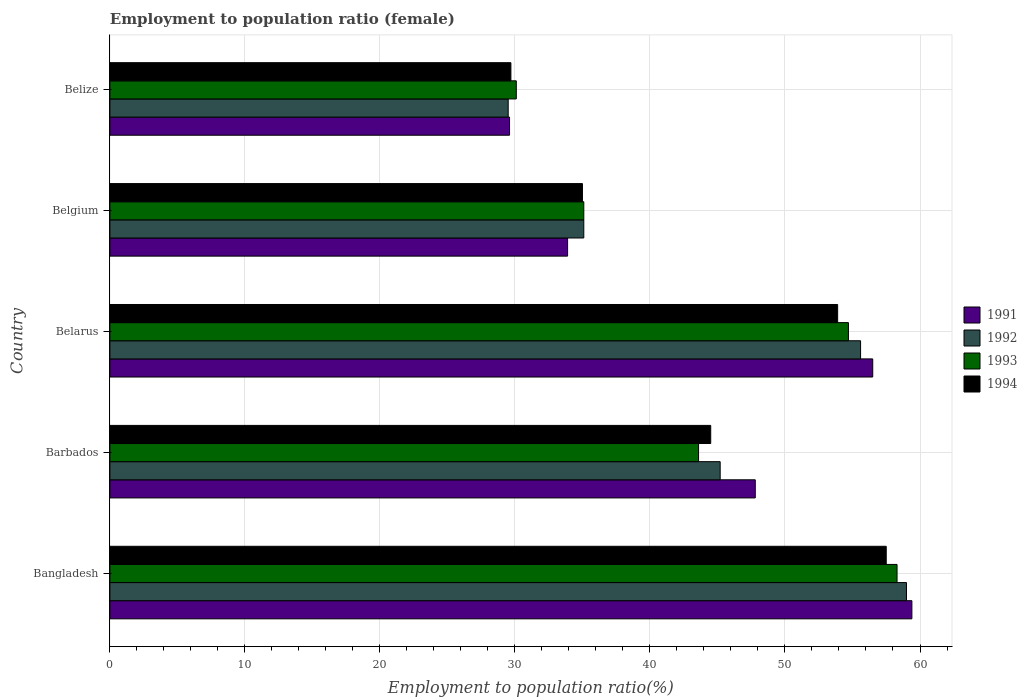How many different coloured bars are there?
Your response must be concise. 4. How many groups of bars are there?
Offer a terse response. 5. Are the number of bars on each tick of the Y-axis equal?
Offer a very short reply. Yes. How many bars are there on the 2nd tick from the top?
Keep it short and to the point. 4. What is the employment to population ratio in 1992 in Barbados?
Provide a short and direct response. 45.2. Across all countries, what is the maximum employment to population ratio in 1994?
Provide a short and direct response. 57.5. Across all countries, what is the minimum employment to population ratio in 1992?
Give a very brief answer. 29.5. In which country was the employment to population ratio in 1992 maximum?
Give a very brief answer. Bangladesh. In which country was the employment to population ratio in 1994 minimum?
Ensure brevity in your answer.  Belize. What is the total employment to population ratio in 1994 in the graph?
Offer a very short reply. 220.6. What is the difference between the employment to population ratio in 1993 in Bangladesh and that in Belgium?
Keep it short and to the point. 23.2. What is the difference between the employment to population ratio in 1991 in Bangladesh and the employment to population ratio in 1994 in Belgium?
Give a very brief answer. 24.4. What is the average employment to population ratio in 1993 per country?
Provide a succinct answer. 44.36. What is the difference between the employment to population ratio in 1992 and employment to population ratio in 1994 in Belize?
Make the answer very short. -0.2. In how many countries, is the employment to population ratio in 1991 greater than 58 %?
Provide a succinct answer. 1. What is the ratio of the employment to population ratio in 1994 in Belarus to that in Belize?
Your response must be concise. 1.81. Is the difference between the employment to population ratio in 1992 in Barbados and Belize greater than the difference between the employment to population ratio in 1994 in Barbados and Belize?
Offer a terse response. Yes. What is the difference between the highest and the second highest employment to population ratio in 1991?
Offer a terse response. 2.9. What is the difference between the highest and the lowest employment to population ratio in 1992?
Your response must be concise. 29.5. In how many countries, is the employment to population ratio in 1991 greater than the average employment to population ratio in 1991 taken over all countries?
Your response must be concise. 3. Is it the case that in every country, the sum of the employment to population ratio in 1994 and employment to population ratio in 1991 is greater than the sum of employment to population ratio in 1993 and employment to population ratio in 1992?
Provide a succinct answer. No. What does the 1st bar from the top in Bangladesh represents?
Make the answer very short. 1994. How many bars are there?
Ensure brevity in your answer.  20. Are all the bars in the graph horizontal?
Provide a succinct answer. Yes. What is the difference between two consecutive major ticks on the X-axis?
Your answer should be compact. 10. Are the values on the major ticks of X-axis written in scientific E-notation?
Keep it short and to the point. No. Does the graph contain any zero values?
Offer a terse response. No. Where does the legend appear in the graph?
Give a very brief answer. Center right. How are the legend labels stacked?
Your answer should be compact. Vertical. What is the title of the graph?
Ensure brevity in your answer.  Employment to population ratio (female). Does "1995" appear as one of the legend labels in the graph?
Provide a short and direct response. No. What is the label or title of the Y-axis?
Your response must be concise. Country. What is the Employment to population ratio(%) in 1991 in Bangladesh?
Provide a short and direct response. 59.4. What is the Employment to population ratio(%) of 1992 in Bangladesh?
Your answer should be very brief. 59. What is the Employment to population ratio(%) in 1993 in Bangladesh?
Your answer should be compact. 58.3. What is the Employment to population ratio(%) in 1994 in Bangladesh?
Offer a very short reply. 57.5. What is the Employment to population ratio(%) in 1991 in Barbados?
Ensure brevity in your answer.  47.8. What is the Employment to population ratio(%) of 1992 in Barbados?
Ensure brevity in your answer.  45.2. What is the Employment to population ratio(%) of 1993 in Barbados?
Give a very brief answer. 43.6. What is the Employment to population ratio(%) in 1994 in Barbados?
Your answer should be compact. 44.5. What is the Employment to population ratio(%) of 1991 in Belarus?
Your response must be concise. 56.5. What is the Employment to population ratio(%) in 1992 in Belarus?
Keep it short and to the point. 55.6. What is the Employment to population ratio(%) in 1993 in Belarus?
Offer a very short reply. 54.7. What is the Employment to population ratio(%) of 1994 in Belarus?
Give a very brief answer. 53.9. What is the Employment to population ratio(%) of 1991 in Belgium?
Your response must be concise. 33.9. What is the Employment to population ratio(%) in 1992 in Belgium?
Make the answer very short. 35.1. What is the Employment to population ratio(%) of 1993 in Belgium?
Offer a terse response. 35.1. What is the Employment to population ratio(%) in 1991 in Belize?
Provide a succinct answer. 29.6. What is the Employment to population ratio(%) of 1992 in Belize?
Offer a very short reply. 29.5. What is the Employment to population ratio(%) in 1993 in Belize?
Provide a succinct answer. 30.1. What is the Employment to population ratio(%) in 1994 in Belize?
Make the answer very short. 29.7. Across all countries, what is the maximum Employment to population ratio(%) of 1991?
Give a very brief answer. 59.4. Across all countries, what is the maximum Employment to population ratio(%) of 1993?
Give a very brief answer. 58.3. Across all countries, what is the maximum Employment to population ratio(%) of 1994?
Make the answer very short. 57.5. Across all countries, what is the minimum Employment to population ratio(%) of 1991?
Give a very brief answer. 29.6. Across all countries, what is the minimum Employment to population ratio(%) in 1992?
Offer a very short reply. 29.5. Across all countries, what is the minimum Employment to population ratio(%) in 1993?
Your answer should be compact. 30.1. Across all countries, what is the minimum Employment to population ratio(%) of 1994?
Provide a short and direct response. 29.7. What is the total Employment to population ratio(%) in 1991 in the graph?
Make the answer very short. 227.2. What is the total Employment to population ratio(%) in 1992 in the graph?
Make the answer very short. 224.4. What is the total Employment to population ratio(%) in 1993 in the graph?
Ensure brevity in your answer.  221.8. What is the total Employment to population ratio(%) of 1994 in the graph?
Your answer should be very brief. 220.6. What is the difference between the Employment to population ratio(%) of 1991 in Bangladesh and that in Belarus?
Make the answer very short. 2.9. What is the difference between the Employment to population ratio(%) in 1992 in Bangladesh and that in Belarus?
Make the answer very short. 3.4. What is the difference between the Employment to population ratio(%) of 1993 in Bangladesh and that in Belarus?
Your answer should be very brief. 3.6. What is the difference between the Employment to population ratio(%) in 1991 in Bangladesh and that in Belgium?
Offer a very short reply. 25.5. What is the difference between the Employment to population ratio(%) of 1992 in Bangladesh and that in Belgium?
Give a very brief answer. 23.9. What is the difference between the Employment to population ratio(%) of 1993 in Bangladesh and that in Belgium?
Give a very brief answer. 23.2. What is the difference between the Employment to population ratio(%) in 1994 in Bangladesh and that in Belgium?
Your answer should be compact. 22.5. What is the difference between the Employment to population ratio(%) of 1991 in Bangladesh and that in Belize?
Offer a terse response. 29.8. What is the difference between the Employment to population ratio(%) in 1992 in Bangladesh and that in Belize?
Keep it short and to the point. 29.5. What is the difference between the Employment to population ratio(%) of 1993 in Bangladesh and that in Belize?
Make the answer very short. 28.2. What is the difference between the Employment to population ratio(%) of 1994 in Bangladesh and that in Belize?
Provide a short and direct response. 27.8. What is the difference between the Employment to population ratio(%) in 1993 in Barbados and that in Belgium?
Your response must be concise. 8.5. What is the difference between the Employment to population ratio(%) in 1991 in Barbados and that in Belize?
Provide a succinct answer. 18.2. What is the difference between the Employment to population ratio(%) of 1992 in Barbados and that in Belize?
Keep it short and to the point. 15.7. What is the difference between the Employment to population ratio(%) in 1994 in Barbados and that in Belize?
Your response must be concise. 14.8. What is the difference between the Employment to population ratio(%) of 1991 in Belarus and that in Belgium?
Make the answer very short. 22.6. What is the difference between the Employment to population ratio(%) of 1992 in Belarus and that in Belgium?
Keep it short and to the point. 20.5. What is the difference between the Employment to population ratio(%) of 1993 in Belarus and that in Belgium?
Offer a very short reply. 19.6. What is the difference between the Employment to population ratio(%) in 1994 in Belarus and that in Belgium?
Make the answer very short. 18.9. What is the difference between the Employment to population ratio(%) in 1991 in Belarus and that in Belize?
Provide a short and direct response. 26.9. What is the difference between the Employment to population ratio(%) in 1992 in Belarus and that in Belize?
Offer a terse response. 26.1. What is the difference between the Employment to population ratio(%) of 1993 in Belarus and that in Belize?
Your answer should be very brief. 24.6. What is the difference between the Employment to population ratio(%) of 1994 in Belarus and that in Belize?
Provide a short and direct response. 24.2. What is the difference between the Employment to population ratio(%) in 1991 in Belgium and that in Belize?
Give a very brief answer. 4.3. What is the difference between the Employment to population ratio(%) of 1993 in Belgium and that in Belize?
Keep it short and to the point. 5. What is the difference between the Employment to population ratio(%) in 1994 in Belgium and that in Belize?
Offer a very short reply. 5.3. What is the difference between the Employment to population ratio(%) of 1991 in Bangladesh and the Employment to population ratio(%) of 1993 in Barbados?
Your answer should be compact. 15.8. What is the difference between the Employment to population ratio(%) of 1992 in Bangladesh and the Employment to population ratio(%) of 1994 in Barbados?
Keep it short and to the point. 14.5. What is the difference between the Employment to population ratio(%) of 1993 in Bangladesh and the Employment to population ratio(%) of 1994 in Barbados?
Keep it short and to the point. 13.8. What is the difference between the Employment to population ratio(%) of 1991 in Bangladesh and the Employment to population ratio(%) of 1992 in Belarus?
Your answer should be compact. 3.8. What is the difference between the Employment to population ratio(%) of 1992 in Bangladesh and the Employment to population ratio(%) of 1994 in Belarus?
Make the answer very short. 5.1. What is the difference between the Employment to population ratio(%) in 1991 in Bangladesh and the Employment to population ratio(%) in 1992 in Belgium?
Your answer should be very brief. 24.3. What is the difference between the Employment to population ratio(%) of 1991 in Bangladesh and the Employment to population ratio(%) of 1993 in Belgium?
Make the answer very short. 24.3. What is the difference between the Employment to population ratio(%) of 1991 in Bangladesh and the Employment to population ratio(%) of 1994 in Belgium?
Provide a short and direct response. 24.4. What is the difference between the Employment to population ratio(%) in 1992 in Bangladesh and the Employment to population ratio(%) in 1993 in Belgium?
Provide a succinct answer. 23.9. What is the difference between the Employment to population ratio(%) of 1992 in Bangladesh and the Employment to population ratio(%) of 1994 in Belgium?
Ensure brevity in your answer.  24. What is the difference between the Employment to population ratio(%) of 1993 in Bangladesh and the Employment to population ratio(%) of 1994 in Belgium?
Keep it short and to the point. 23.3. What is the difference between the Employment to population ratio(%) in 1991 in Bangladesh and the Employment to population ratio(%) in 1992 in Belize?
Your answer should be compact. 29.9. What is the difference between the Employment to population ratio(%) in 1991 in Bangladesh and the Employment to population ratio(%) in 1993 in Belize?
Your response must be concise. 29.3. What is the difference between the Employment to population ratio(%) of 1991 in Bangladesh and the Employment to population ratio(%) of 1994 in Belize?
Offer a very short reply. 29.7. What is the difference between the Employment to population ratio(%) in 1992 in Bangladesh and the Employment to population ratio(%) in 1993 in Belize?
Offer a very short reply. 28.9. What is the difference between the Employment to population ratio(%) of 1992 in Bangladesh and the Employment to population ratio(%) of 1994 in Belize?
Provide a succinct answer. 29.3. What is the difference between the Employment to population ratio(%) of 1993 in Bangladesh and the Employment to population ratio(%) of 1994 in Belize?
Give a very brief answer. 28.6. What is the difference between the Employment to population ratio(%) in 1991 in Barbados and the Employment to population ratio(%) in 1994 in Belarus?
Offer a terse response. -6.1. What is the difference between the Employment to population ratio(%) of 1992 in Barbados and the Employment to population ratio(%) of 1993 in Belarus?
Ensure brevity in your answer.  -9.5. What is the difference between the Employment to population ratio(%) of 1992 in Barbados and the Employment to population ratio(%) of 1994 in Belarus?
Your answer should be very brief. -8.7. What is the difference between the Employment to population ratio(%) of 1991 in Barbados and the Employment to population ratio(%) of 1993 in Belgium?
Ensure brevity in your answer.  12.7. What is the difference between the Employment to population ratio(%) in 1991 in Barbados and the Employment to population ratio(%) in 1994 in Belgium?
Your answer should be very brief. 12.8. What is the difference between the Employment to population ratio(%) of 1993 in Barbados and the Employment to population ratio(%) of 1994 in Belgium?
Give a very brief answer. 8.6. What is the difference between the Employment to population ratio(%) of 1991 in Barbados and the Employment to population ratio(%) of 1992 in Belize?
Make the answer very short. 18.3. What is the difference between the Employment to population ratio(%) in 1991 in Barbados and the Employment to population ratio(%) in 1993 in Belize?
Your answer should be compact. 17.7. What is the difference between the Employment to population ratio(%) in 1991 in Barbados and the Employment to population ratio(%) in 1994 in Belize?
Offer a terse response. 18.1. What is the difference between the Employment to population ratio(%) of 1992 in Barbados and the Employment to population ratio(%) of 1993 in Belize?
Ensure brevity in your answer.  15.1. What is the difference between the Employment to population ratio(%) in 1992 in Barbados and the Employment to population ratio(%) in 1994 in Belize?
Give a very brief answer. 15.5. What is the difference between the Employment to population ratio(%) of 1993 in Barbados and the Employment to population ratio(%) of 1994 in Belize?
Give a very brief answer. 13.9. What is the difference between the Employment to population ratio(%) in 1991 in Belarus and the Employment to population ratio(%) in 1992 in Belgium?
Your answer should be compact. 21.4. What is the difference between the Employment to population ratio(%) in 1991 in Belarus and the Employment to population ratio(%) in 1993 in Belgium?
Provide a short and direct response. 21.4. What is the difference between the Employment to population ratio(%) in 1992 in Belarus and the Employment to population ratio(%) in 1994 in Belgium?
Provide a short and direct response. 20.6. What is the difference between the Employment to population ratio(%) in 1993 in Belarus and the Employment to population ratio(%) in 1994 in Belgium?
Ensure brevity in your answer.  19.7. What is the difference between the Employment to population ratio(%) in 1991 in Belarus and the Employment to population ratio(%) in 1992 in Belize?
Offer a very short reply. 27. What is the difference between the Employment to population ratio(%) in 1991 in Belarus and the Employment to population ratio(%) in 1993 in Belize?
Your answer should be compact. 26.4. What is the difference between the Employment to population ratio(%) of 1991 in Belarus and the Employment to population ratio(%) of 1994 in Belize?
Provide a succinct answer. 26.8. What is the difference between the Employment to population ratio(%) in 1992 in Belarus and the Employment to population ratio(%) in 1993 in Belize?
Your answer should be compact. 25.5. What is the difference between the Employment to population ratio(%) of 1992 in Belarus and the Employment to population ratio(%) of 1994 in Belize?
Offer a terse response. 25.9. What is the difference between the Employment to population ratio(%) in 1993 in Belarus and the Employment to population ratio(%) in 1994 in Belize?
Provide a short and direct response. 25. What is the difference between the Employment to population ratio(%) in 1991 in Belgium and the Employment to population ratio(%) in 1994 in Belize?
Your response must be concise. 4.2. What is the difference between the Employment to population ratio(%) of 1992 in Belgium and the Employment to population ratio(%) of 1993 in Belize?
Give a very brief answer. 5. What is the difference between the Employment to population ratio(%) in 1993 in Belgium and the Employment to population ratio(%) in 1994 in Belize?
Your answer should be compact. 5.4. What is the average Employment to population ratio(%) of 1991 per country?
Provide a short and direct response. 45.44. What is the average Employment to population ratio(%) in 1992 per country?
Provide a short and direct response. 44.88. What is the average Employment to population ratio(%) of 1993 per country?
Keep it short and to the point. 44.36. What is the average Employment to population ratio(%) in 1994 per country?
Provide a succinct answer. 44.12. What is the difference between the Employment to population ratio(%) of 1991 and Employment to population ratio(%) of 1993 in Bangladesh?
Give a very brief answer. 1.1. What is the difference between the Employment to population ratio(%) in 1991 and Employment to population ratio(%) in 1994 in Bangladesh?
Offer a very short reply. 1.9. What is the difference between the Employment to population ratio(%) in 1992 and Employment to population ratio(%) in 1994 in Bangladesh?
Your response must be concise. 1.5. What is the difference between the Employment to population ratio(%) in 1993 and Employment to population ratio(%) in 1994 in Bangladesh?
Your answer should be very brief. 0.8. What is the difference between the Employment to population ratio(%) of 1992 and Employment to population ratio(%) of 1993 in Barbados?
Offer a terse response. 1.6. What is the difference between the Employment to population ratio(%) of 1992 and Employment to population ratio(%) of 1994 in Barbados?
Make the answer very short. 0.7. What is the difference between the Employment to population ratio(%) of 1993 and Employment to population ratio(%) of 1994 in Barbados?
Give a very brief answer. -0.9. What is the difference between the Employment to population ratio(%) in 1991 and Employment to population ratio(%) in 1994 in Belarus?
Make the answer very short. 2.6. What is the difference between the Employment to population ratio(%) in 1993 and Employment to population ratio(%) in 1994 in Belarus?
Provide a succinct answer. 0.8. What is the difference between the Employment to population ratio(%) of 1991 and Employment to population ratio(%) of 1992 in Belgium?
Give a very brief answer. -1.2. What is the difference between the Employment to population ratio(%) of 1991 and Employment to population ratio(%) of 1993 in Belgium?
Provide a succinct answer. -1.2. What is the difference between the Employment to population ratio(%) of 1992 and Employment to population ratio(%) of 1993 in Belgium?
Your answer should be very brief. 0. What is the difference between the Employment to population ratio(%) of 1993 and Employment to population ratio(%) of 1994 in Belgium?
Your response must be concise. 0.1. What is the difference between the Employment to population ratio(%) in 1991 and Employment to population ratio(%) in 1993 in Belize?
Your response must be concise. -0.5. What is the difference between the Employment to population ratio(%) in 1991 and Employment to population ratio(%) in 1994 in Belize?
Your response must be concise. -0.1. What is the difference between the Employment to population ratio(%) of 1992 and Employment to population ratio(%) of 1993 in Belize?
Offer a very short reply. -0.6. What is the ratio of the Employment to population ratio(%) in 1991 in Bangladesh to that in Barbados?
Your response must be concise. 1.24. What is the ratio of the Employment to population ratio(%) of 1992 in Bangladesh to that in Barbados?
Make the answer very short. 1.31. What is the ratio of the Employment to population ratio(%) in 1993 in Bangladesh to that in Barbados?
Offer a terse response. 1.34. What is the ratio of the Employment to population ratio(%) in 1994 in Bangladesh to that in Barbados?
Provide a short and direct response. 1.29. What is the ratio of the Employment to population ratio(%) of 1991 in Bangladesh to that in Belarus?
Offer a terse response. 1.05. What is the ratio of the Employment to population ratio(%) of 1992 in Bangladesh to that in Belarus?
Offer a terse response. 1.06. What is the ratio of the Employment to population ratio(%) in 1993 in Bangladesh to that in Belarus?
Provide a succinct answer. 1.07. What is the ratio of the Employment to population ratio(%) in 1994 in Bangladesh to that in Belarus?
Provide a succinct answer. 1.07. What is the ratio of the Employment to population ratio(%) of 1991 in Bangladesh to that in Belgium?
Your response must be concise. 1.75. What is the ratio of the Employment to population ratio(%) in 1992 in Bangladesh to that in Belgium?
Offer a very short reply. 1.68. What is the ratio of the Employment to population ratio(%) in 1993 in Bangladesh to that in Belgium?
Offer a terse response. 1.66. What is the ratio of the Employment to population ratio(%) in 1994 in Bangladesh to that in Belgium?
Give a very brief answer. 1.64. What is the ratio of the Employment to population ratio(%) in 1991 in Bangladesh to that in Belize?
Keep it short and to the point. 2.01. What is the ratio of the Employment to population ratio(%) in 1993 in Bangladesh to that in Belize?
Offer a terse response. 1.94. What is the ratio of the Employment to population ratio(%) in 1994 in Bangladesh to that in Belize?
Your answer should be very brief. 1.94. What is the ratio of the Employment to population ratio(%) of 1991 in Barbados to that in Belarus?
Keep it short and to the point. 0.85. What is the ratio of the Employment to population ratio(%) in 1992 in Barbados to that in Belarus?
Ensure brevity in your answer.  0.81. What is the ratio of the Employment to population ratio(%) in 1993 in Barbados to that in Belarus?
Offer a very short reply. 0.8. What is the ratio of the Employment to population ratio(%) of 1994 in Barbados to that in Belarus?
Provide a succinct answer. 0.83. What is the ratio of the Employment to population ratio(%) of 1991 in Barbados to that in Belgium?
Your response must be concise. 1.41. What is the ratio of the Employment to population ratio(%) in 1992 in Barbados to that in Belgium?
Your response must be concise. 1.29. What is the ratio of the Employment to population ratio(%) of 1993 in Barbados to that in Belgium?
Your answer should be compact. 1.24. What is the ratio of the Employment to population ratio(%) of 1994 in Barbados to that in Belgium?
Give a very brief answer. 1.27. What is the ratio of the Employment to population ratio(%) in 1991 in Barbados to that in Belize?
Your answer should be compact. 1.61. What is the ratio of the Employment to population ratio(%) in 1992 in Barbados to that in Belize?
Ensure brevity in your answer.  1.53. What is the ratio of the Employment to population ratio(%) of 1993 in Barbados to that in Belize?
Give a very brief answer. 1.45. What is the ratio of the Employment to population ratio(%) of 1994 in Barbados to that in Belize?
Make the answer very short. 1.5. What is the ratio of the Employment to population ratio(%) of 1991 in Belarus to that in Belgium?
Ensure brevity in your answer.  1.67. What is the ratio of the Employment to population ratio(%) in 1992 in Belarus to that in Belgium?
Your answer should be compact. 1.58. What is the ratio of the Employment to population ratio(%) of 1993 in Belarus to that in Belgium?
Keep it short and to the point. 1.56. What is the ratio of the Employment to population ratio(%) of 1994 in Belarus to that in Belgium?
Provide a succinct answer. 1.54. What is the ratio of the Employment to population ratio(%) of 1991 in Belarus to that in Belize?
Provide a succinct answer. 1.91. What is the ratio of the Employment to population ratio(%) in 1992 in Belarus to that in Belize?
Provide a short and direct response. 1.88. What is the ratio of the Employment to population ratio(%) of 1993 in Belarus to that in Belize?
Offer a terse response. 1.82. What is the ratio of the Employment to population ratio(%) in 1994 in Belarus to that in Belize?
Offer a very short reply. 1.81. What is the ratio of the Employment to population ratio(%) of 1991 in Belgium to that in Belize?
Your response must be concise. 1.15. What is the ratio of the Employment to population ratio(%) of 1992 in Belgium to that in Belize?
Your response must be concise. 1.19. What is the ratio of the Employment to population ratio(%) of 1993 in Belgium to that in Belize?
Make the answer very short. 1.17. What is the ratio of the Employment to population ratio(%) in 1994 in Belgium to that in Belize?
Your answer should be very brief. 1.18. What is the difference between the highest and the second highest Employment to population ratio(%) of 1991?
Your response must be concise. 2.9. What is the difference between the highest and the second highest Employment to population ratio(%) of 1993?
Offer a terse response. 3.6. What is the difference between the highest and the second highest Employment to population ratio(%) of 1994?
Provide a short and direct response. 3.6. What is the difference between the highest and the lowest Employment to population ratio(%) of 1991?
Your answer should be compact. 29.8. What is the difference between the highest and the lowest Employment to population ratio(%) in 1992?
Your response must be concise. 29.5. What is the difference between the highest and the lowest Employment to population ratio(%) of 1993?
Your response must be concise. 28.2. What is the difference between the highest and the lowest Employment to population ratio(%) of 1994?
Keep it short and to the point. 27.8. 